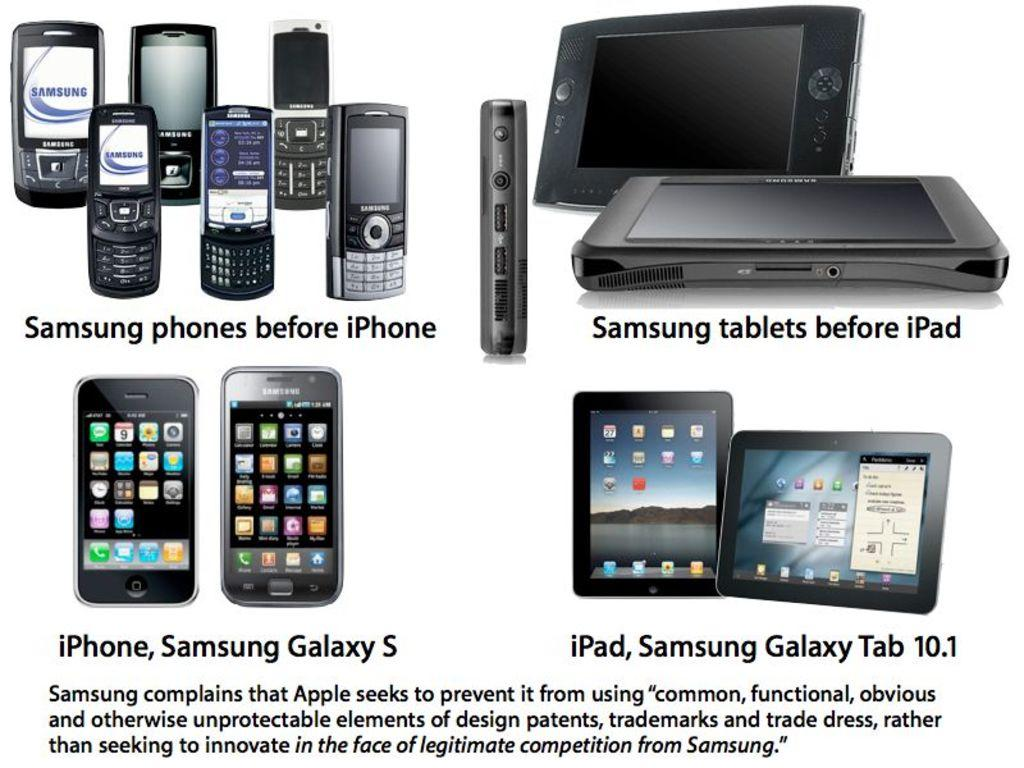Provide a one-sentence caption for the provided image. An advert for Samsun phones and tablets professing their superiority over Apple products. 